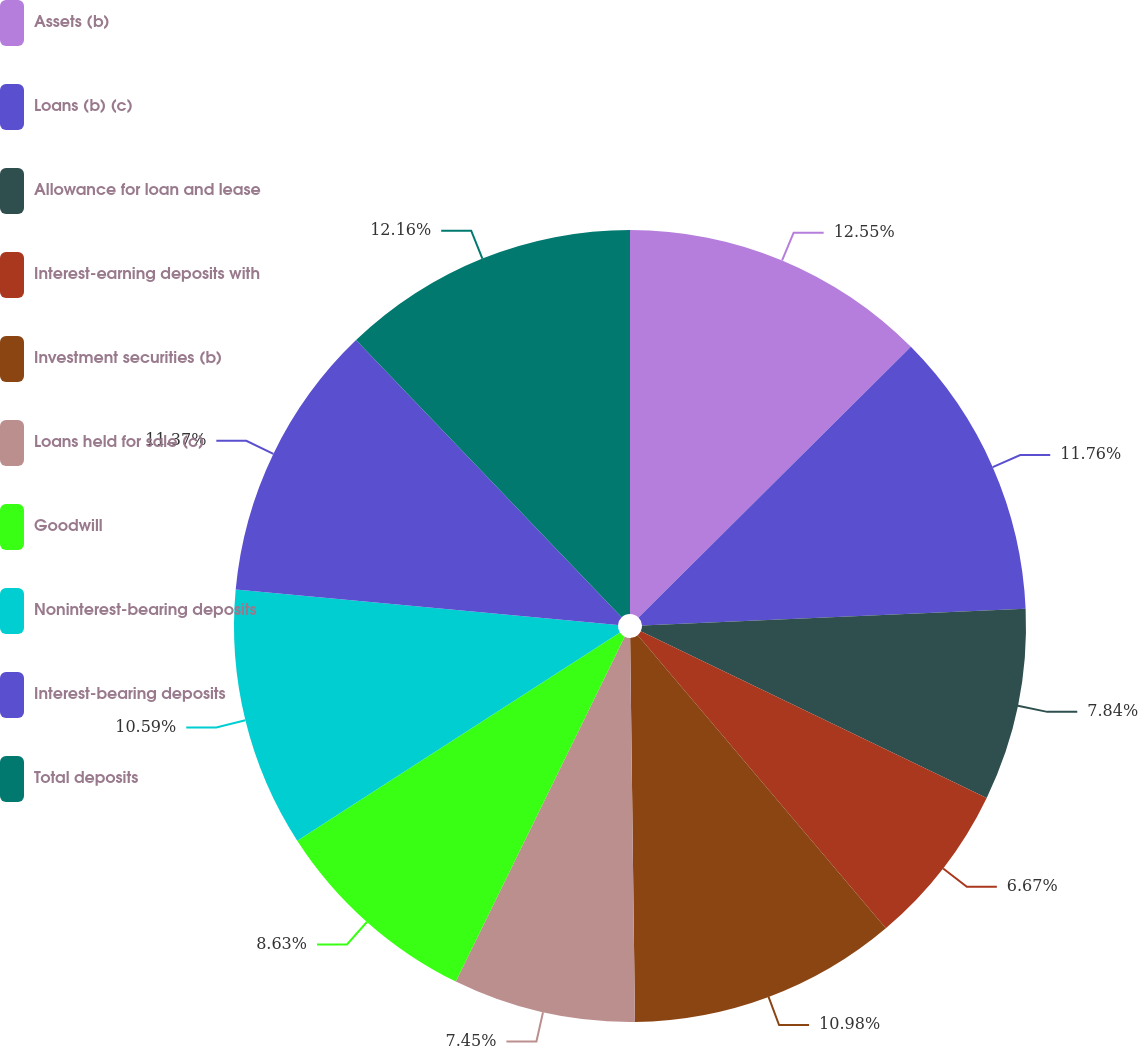Convert chart to OTSL. <chart><loc_0><loc_0><loc_500><loc_500><pie_chart><fcel>Assets (b)<fcel>Loans (b) (c)<fcel>Allowance for loan and lease<fcel>Interest-earning deposits with<fcel>Investment securities (b)<fcel>Loans held for sale (c)<fcel>Goodwill<fcel>Noninterest-bearing deposits<fcel>Interest-bearing deposits<fcel>Total deposits<nl><fcel>12.55%<fcel>11.76%<fcel>7.84%<fcel>6.67%<fcel>10.98%<fcel>7.45%<fcel>8.63%<fcel>10.59%<fcel>11.37%<fcel>12.16%<nl></chart> 